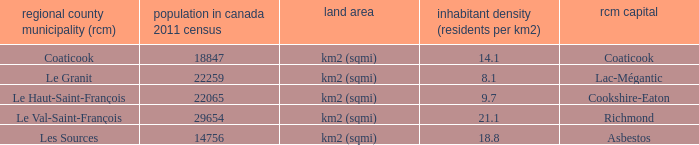What is the seat of the county that has a density of 14.1? Coaticook. 